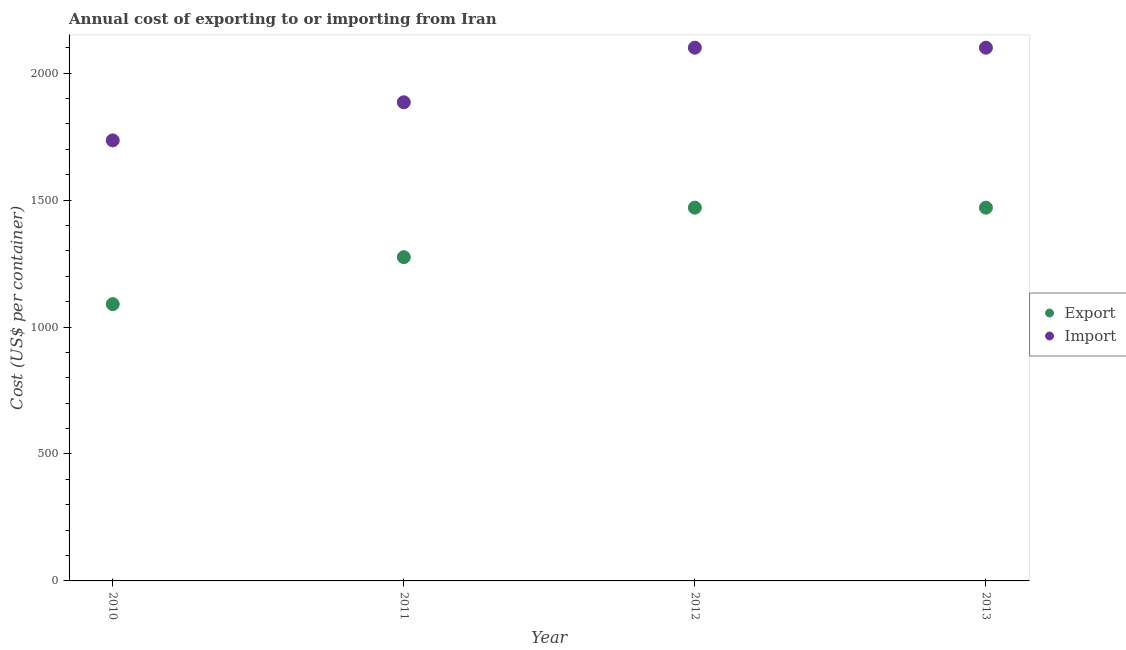How many different coloured dotlines are there?
Make the answer very short. 2. What is the export cost in 2012?
Keep it short and to the point. 1470. Across all years, what is the maximum export cost?
Offer a terse response. 1470. Across all years, what is the minimum import cost?
Make the answer very short. 1735. In which year was the import cost maximum?
Provide a succinct answer. 2012. In which year was the export cost minimum?
Give a very brief answer. 2010. What is the total import cost in the graph?
Offer a very short reply. 7820. What is the difference between the export cost in 2010 and that in 2012?
Offer a very short reply. -380. What is the difference between the import cost in 2012 and the export cost in 2013?
Provide a succinct answer. 630. What is the average import cost per year?
Provide a short and direct response. 1955. In the year 2013, what is the difference between the export cost and import cost?
Your answer should be very brief. -630. In how many years, is the export cost greater than 1400 US$?
Offer a very short reply. 2. What is the ratio of the import cost in 2010 to that in 2011?
Offer a terse response. 0.92. Is the import cost in 2010 less than that in 2011?
Make the answer very short. Yes. What is the difference between the highest and the second highest import cost?
Provide a succinct answer. 0. What is the difference between the highest and the lowest export cost?
Your answer should be very brief. 380. In how many years, is the export cost greater than the average export cost taken over all years?
Offer a very short reply. 2. Is the export cost strictly greater than the import cost over the years?
Give a very brief answer. No. How many years are there in the graph?
Provide a succinct answer. 4. Does the graph contain any zero values?
Make the answer very short. No. Where does the legend appear in the graph?
Keep it short and to the point. Center right. How many legend labels are there?
Provide a short and direct response. 2. How are the legend labels stacked?
Give a very brief answer. Vertical. What is the title of the graph?
Offer a very short reply. Annual cost of exporting to or importing from Iran. What is the label or title of the Y-axis?
Provide a succinct answer. Cost (US$ per container). What is the Cost (US$ per container) of Export in 2010?
Your response must be concise. 1090. What is the Cost (US$ per container) in Import in 2010?
Your response must be concise. 1735. What is the Cost (US$ per container) of Export in 2011?
Your answer should be compact. 1275. What is the Cost (US$ per container) in Import in 2011?
Your answer should be compact. 1885. What is the Cost (US$ per container) in Export in 2012?
Your answer should be compact. 1470. What is the Cost (US$ per container) of Import in 2012?
Your answer should be compact. 2100. What is the Cost (US$ per container) of Export in 2013?
Provide a short and direct response. 1470. What is the Cost (US$ per container) of Import in 2013?
Make the answer very short. 2100. Across all years, what is the maximum Cost (US$ per container) in Export?
Your response must be concise. 1470. Across all years, what is the maximum Cost (US$ per container) in Import?
Your answer should be compact. 2100. Across all years, what is the minimum Cost (US$ per container) of Export?
Make the answer very short. 1090. Across all years, what is the minimum Cost (US$ per container) of Import?
Your answer should be very brief. 1735. What is the total Cost (US$ per container) of Export in the graph?
Your response must be concise. 5305. What is the total Cost (US$ per container) of Import in the graph?
Your answer should be very brief. 7820. What is the difference between the Cost (US$ per container) in Export in 2010 and that in 2011?
Give a very brief answer. -185. What is the difference between the Cost (US$ per container) in Import in 2010 and that in 2011?
Provide a succinct answer. -150. What is the difference between the Cost (US$ per container) in Export in 2010 and that in 2012?
Offer a very short reply. -380. What is the difference between the Cost (US$ per container) in Import in 2010 and that in 2012?
Provide a short and direct response. -365. What is the difference between the Cost (US$ per container) in Export in 2010 and that in 2013?
Your answer should be very brief. -380. What is the difference between the Cost (US$ per container) in Import in 2010 and that in 2013?
Your answer should be very brief. -365. What is the difference between the Cost (US$ per container) of Export in 2011 and that in 2012?
Provide a short and direct response. -195. What is the difference between the Cost (US$ per container) in Import in 2011 and that in 2012?
Your answer should be very brief. -215. What is the difference between the Cost (US$ per container) in Export in 2011 and that in 2013?
Provide a short and direct response. -195. What is the difference between the Cost (US$ per container) of Import in 2011 and that in 2013?
Your answer should be very brief. -215. What is the difference between the Cost (US$ per container) in Export in 2012 and that in 2013?
Your answer should be very brief. 0. What is the difference between the Cost (US$ per container) of Import in 2012 and that in 2013?
Offer a very short reply. 0. What is the difference between the Cost (US$ per container) in Export in 2010 and the Cost (US$ per container) in Import in 2011?
Provide a short and direct response. -795. What is the difference between the Cost (US$ per container) in Export in 2010 and the Cost (US$ per container) in Import in 2012?
Ensure brevity in your answer.  -1010. What is the difference between the Cost (US$ per container) of Export in 2010 and the Cost (US$ per container) of Import in 2013?
Your answer should be very brief. -1010. What is the difference between the Cost (US$ per container) in Export in 2011 and the Cost (US$ per container) in Import in 2012?
Offer a very short reply. -825. What is the difference between the Cost (US$ per container) of Export in 2011 and the Cost (US$ per container) of Import in 2013?
Offer a terse response. -825. What is the difference between the Cost (US$ per container) in Export in 2012 and the Cost (US$ per container) in Import in 2013?
Make the answer very short. -630. What is the average Cost (US$ per container) of Export per year?
Your answer should be very brief. 1326.25. What is the average Cost (US$ per container) of Import per year?
Your response must be concise. 1955. In the year 2010, what is the difference between the Cost (US$ per container) of Export and Cost (US$ per container) of Import?
Your answer should be compact. -645. In the year 2011, what is the difference between the Cost (US$ per container) in Export and Cost (US$ per container) in Import?
Offer a very short reply. -610. In the year 2012, what is the difference between the Cost (US$ per container) of Export and Cost (US$ per container) of Import?
Make the answer very short. -630. In the year 2013, what is the difference between the Cost (US$ per container) in Export and Cost (US$ per container) in Import?
Your answer should be compact. -630. What is the ratio of the Cost (US$ per container) of Export in 2010 to that in 2011?
Provide a short and direct response. 0.85. What is the ratio of the Cost (US$ per container) in Import in 2010 to that in 2011?
Ensure brevity in your answer.  0.92. What is the ratio of the Cost (US$ per container) of Export in 2010 to that in 2012?
Provide a succinct answer. 0.74. What is the ratio of the Cost (US$ per container) in Import in 2010 to that in 2012?
Your answer should be very brief. 0.83. What is the ratio of the Cost (US$ per container) of Export in 2010 to that in 2013?
Your answer should be compact. 0.74. What is the ratio of the Cost (US$ per container) in Import in 2010 to that in 2013?
Give a very brief answer. 0.83. What is the ratio of the Cost (US$ per container) of Export in 2011 to that in 2012?
Ensure brevity in your answer.  0.87. What is the ratio of the Cost (US$ per container) in Import in 2011 to that in 2012?
Offer a terse response. 0.9. What is the ratio of the Cost (US$ per container) of Export in 2011 to that in 2013?
Your response must be concise. 0.87. What is the ratio of the Cost (US$ per container) of Import in 2011 to that in 2013?
Ensure brevity in your answer.  0.9. What is the ratio of the Cost (US$ per container) in Import in 2012 to that in 2013?
Give a very brief answer. 1. What is the difference between the highest and the lowest Cost (US$ per container) of Export?
Make the answer very short. 380. What is the difference between the highest and the lowest Cost (US$ per container) of Import?
Your answer should be compact. 365. 